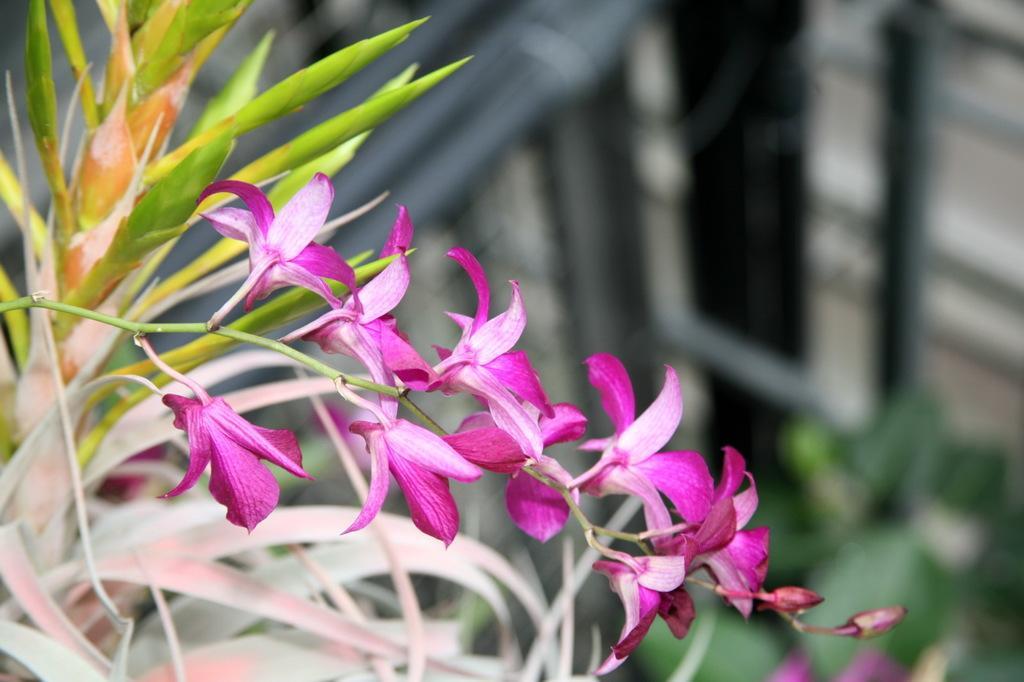Could you give a brief overview of what you see in this image? In this image we can see some flowers to the stem of a plant. 